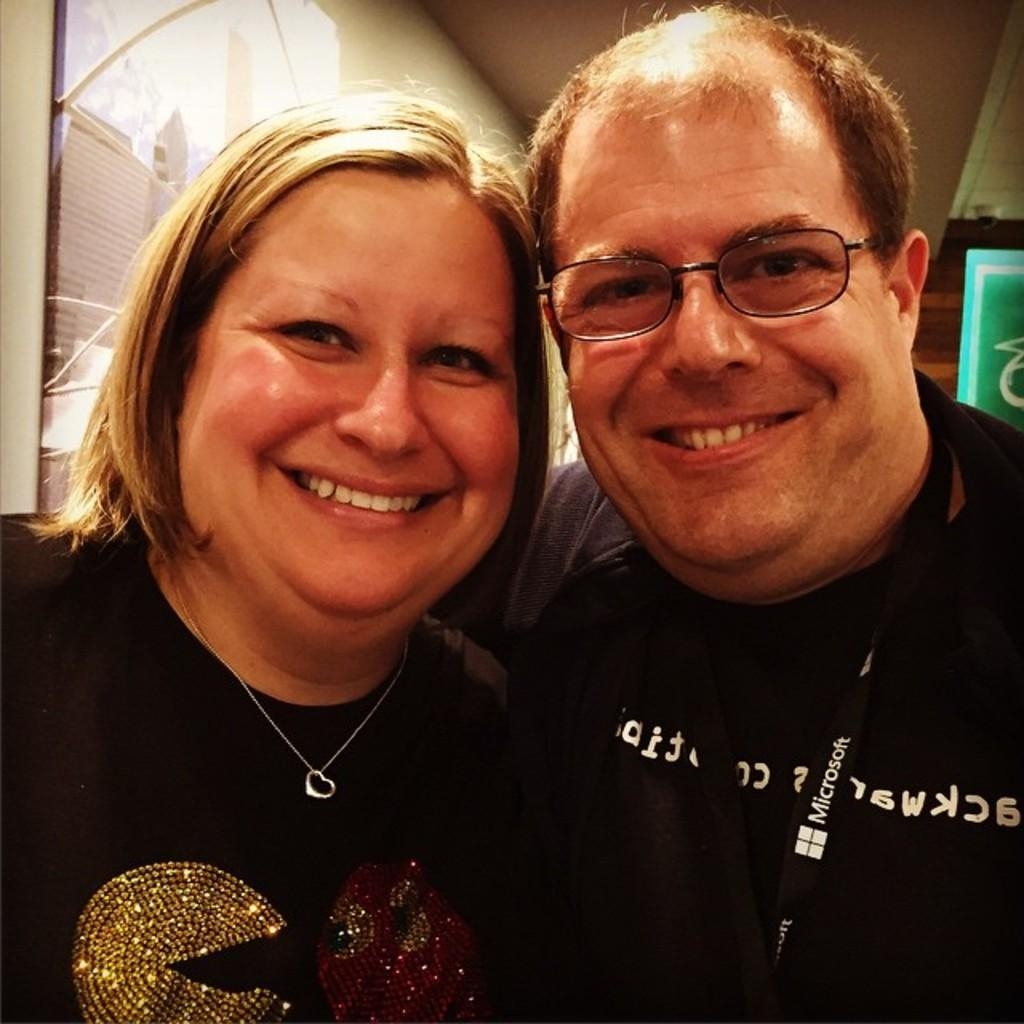How many people are present in the image? There are two people, a man and a woman, present in the image. What are the man and woman doing in the image? The man and woman are standing. What can be seen in the background of the image? There is a wall in the background of the image. What type of cake is being served in the image? There is no cake present in the image; it features a man and a woman standing in front of a wall. 